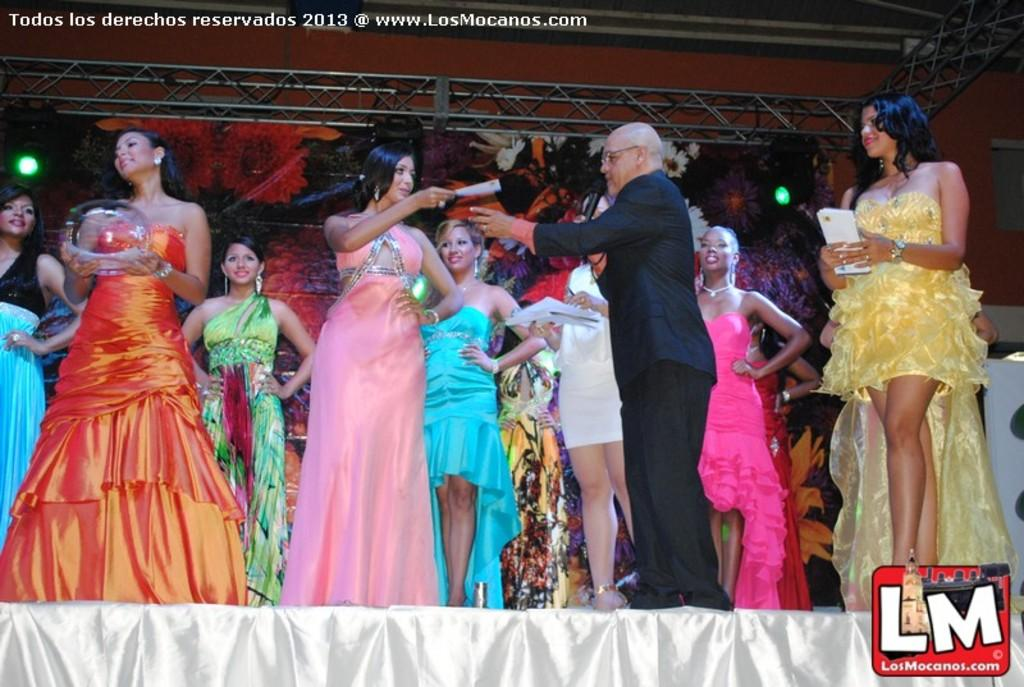What is happening in the foreground of the image? There are people standing on the stage in the foreground. Can you describe the appearance of one of the people on stage? There is a person wearing a black coat. What is the person in the black coat doing? The person in the black coat is holding a microphone. What can be seen in the background of the image? There are lights in the background. What type of fork is being used to serve lunch on stage? There is no fork or lunch present in the image; it features people standing on a stage with a person holding a microphone. 